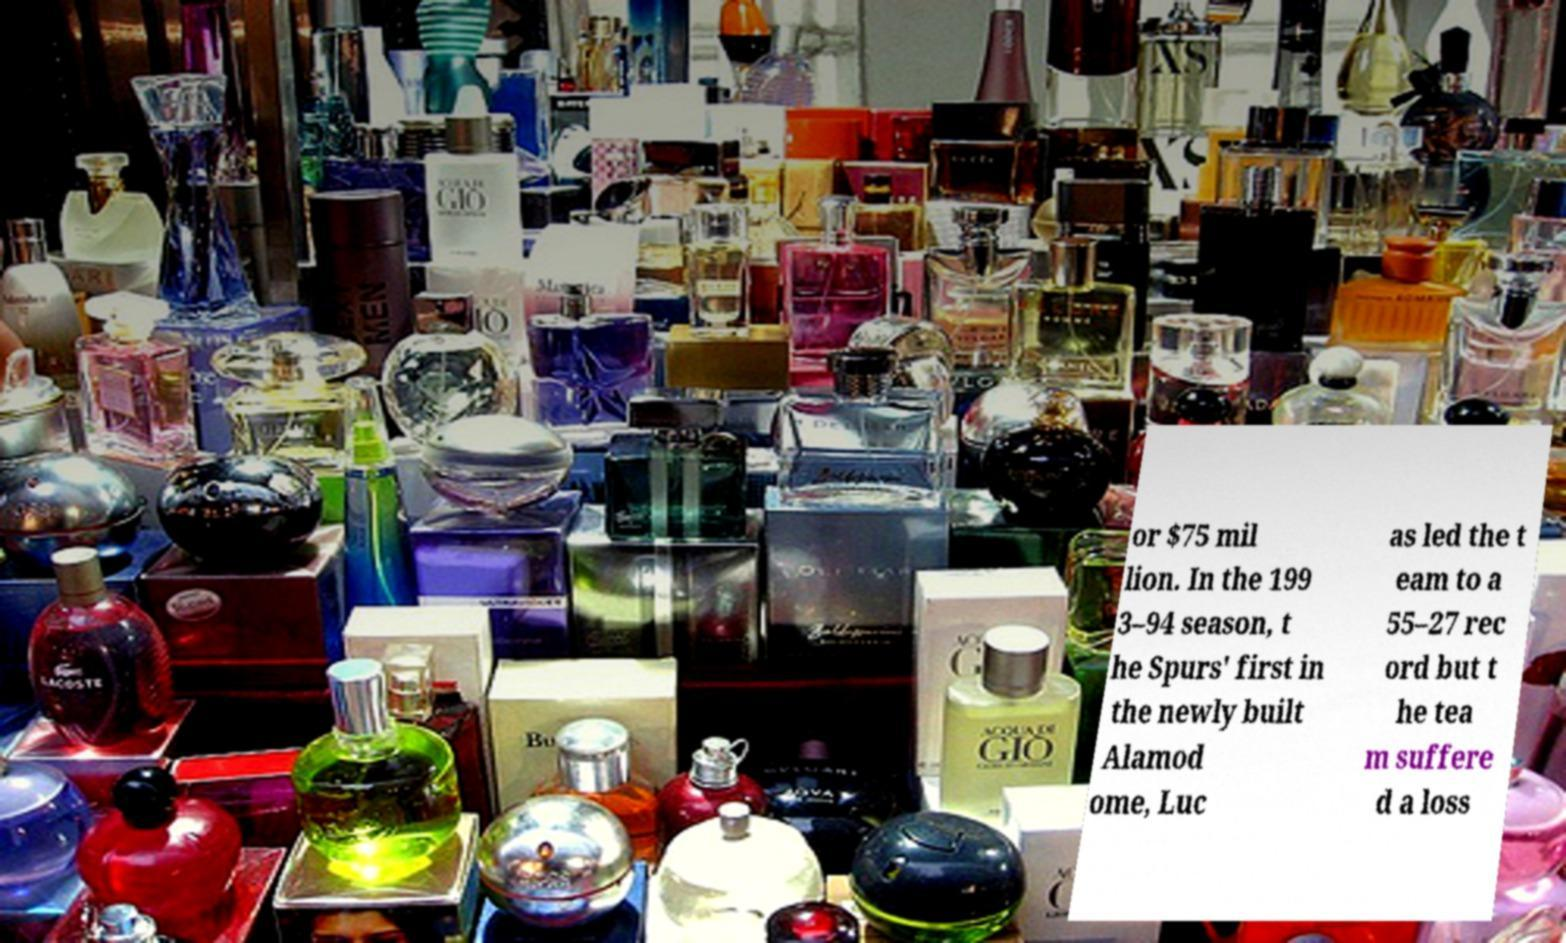For documentation purposes, I need the text within this image transcribed. Could you provide that? or $75 mil lion. In the 199 3–94 season, t he Spurs' first in the newly built Alamod ome, Luc as led the t eam to a 55–27 rec ord but t he tea m suffere d a loss 